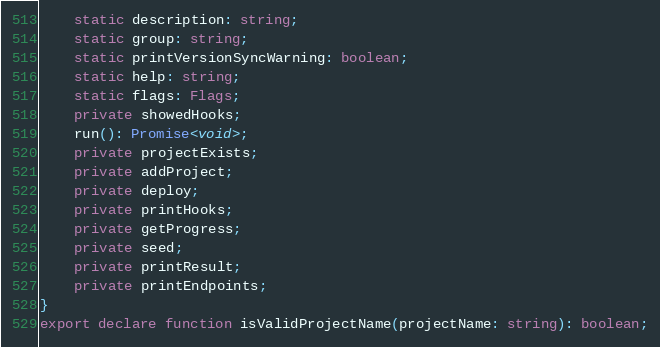Convert code to text. <code><loc_0><loc_0><loc_500><loc_500><_TypeScript_>    static description: string;
    static group: string;
    static printVersionSyncWarning: boolean;
    static help: string;
    static flags: Flags;
    private showedHooks;
    run(): Promise<void>;
    private projectExists;
    private addProject;
    private deploy;
    private printHooks;
    private getProgress;
    private seed;
    private printResult;
    private printEndpoints;
}
export declare function isValidProjectName(projectName: string): boolean;
</code> 